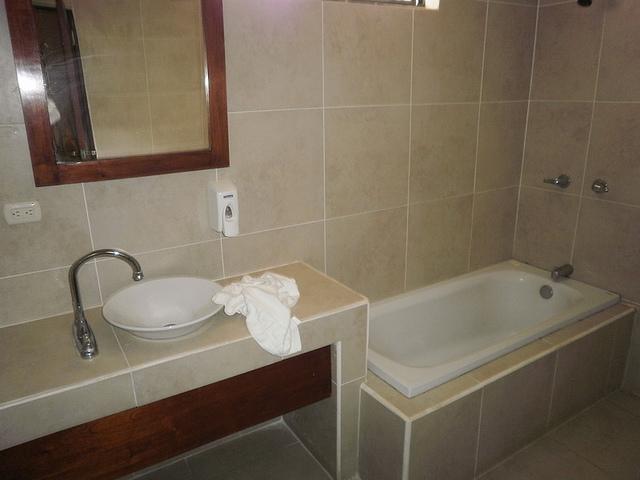What decor is on the tile?
Be succinct. Beige. Is the sink clean?
Keep it brief. Yes. What color is the stripe on wall?
Concise answer only. White. What is missing near the shower area?
Concise answer only. Curtain. Is the towel hung up?
Concise answer only. No. What color is the towel?
Quick response, please. White. 